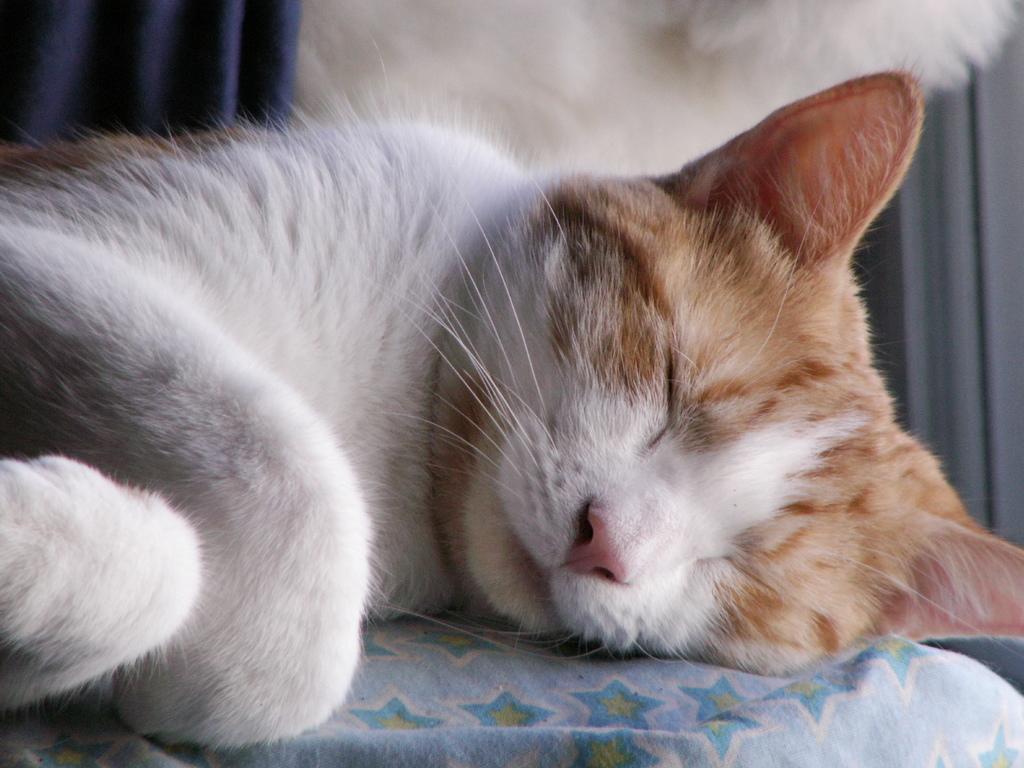Could you give a brief overview of what you see in this image? In this picture we can see a cat on a platform, here we can see a cloth and in the background we can see a white color object and curtains. 